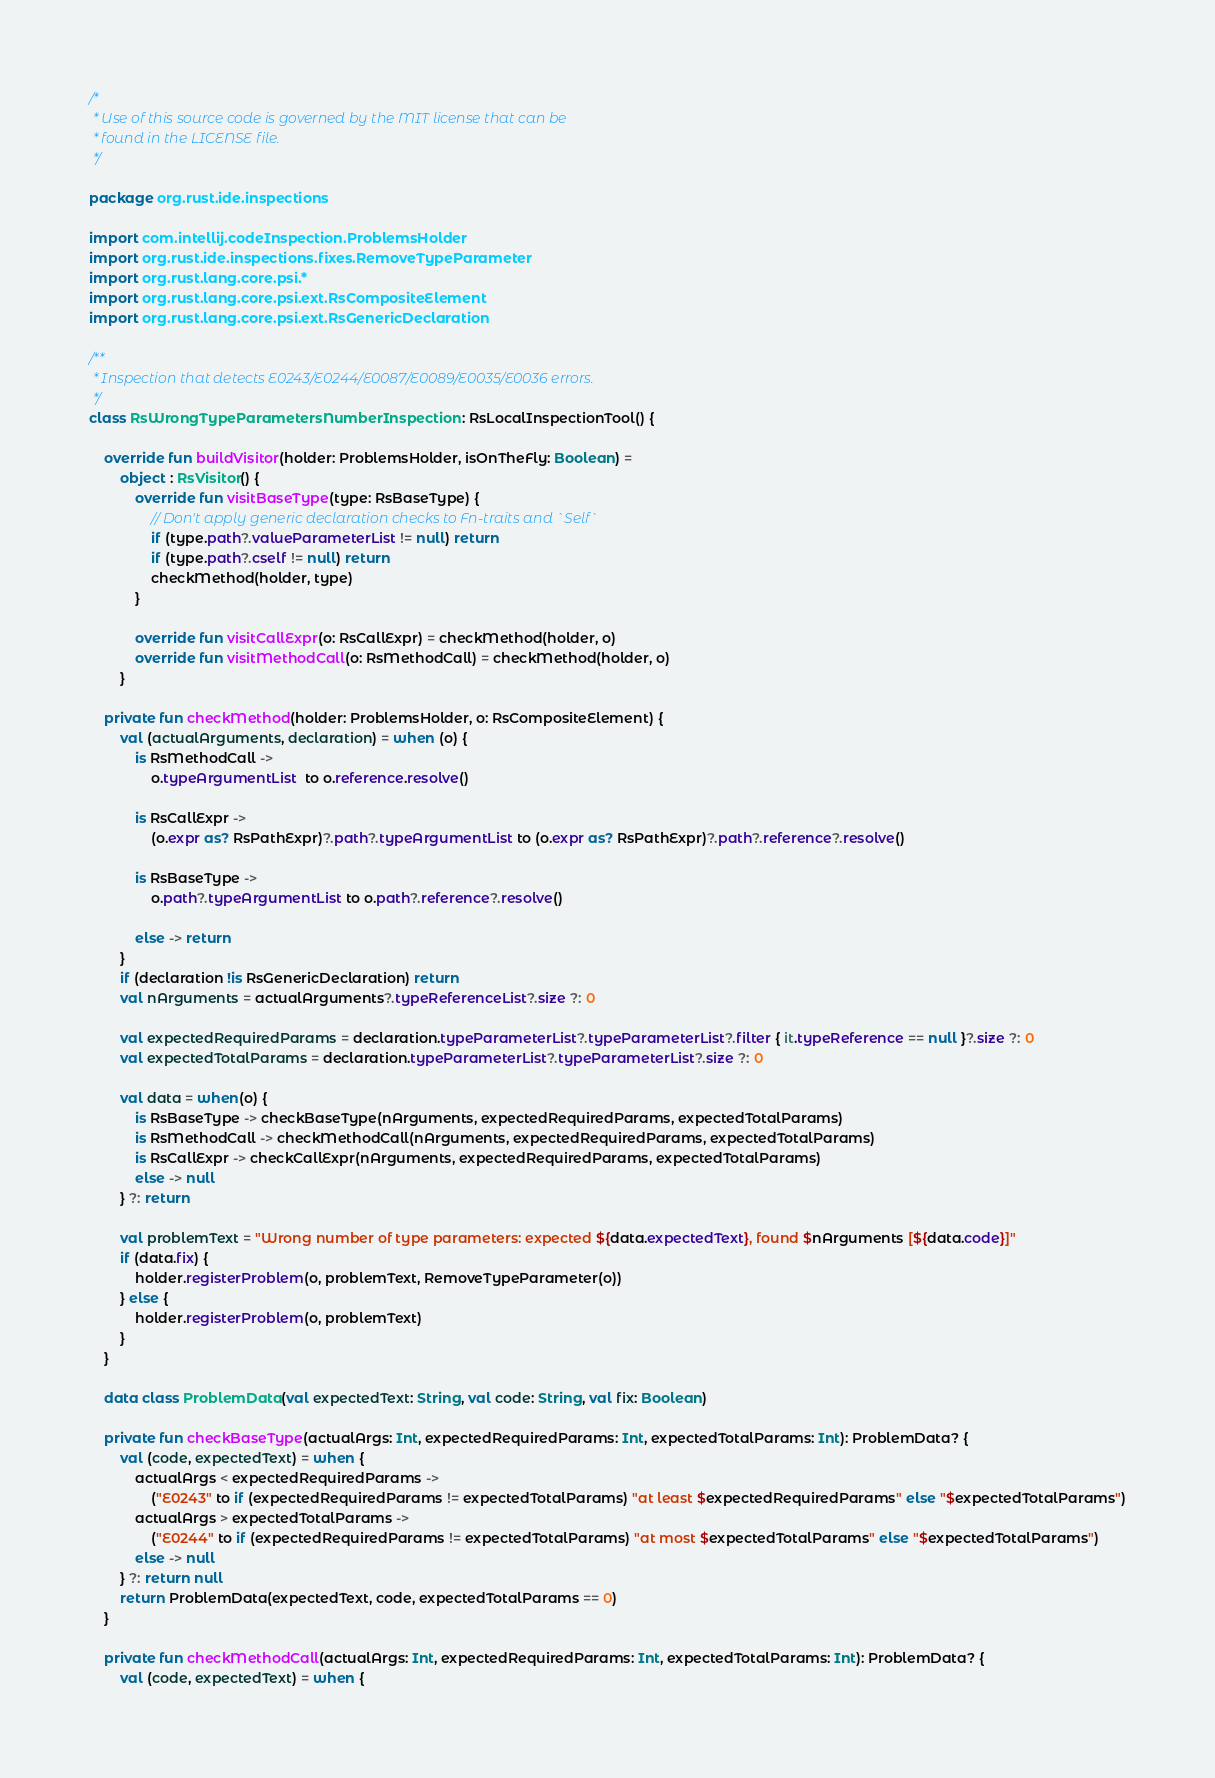<code> <loc_0><loc_0><loc_500><loc_500><_Kotlin_>/*
 * Use of this source code is governed by the MIT license that can be
 * found in the LICENSE file.
 */

package org.rust.ide.inspections

import com.intellij.codeInspection.ProblemsHolder
import org.rust.ide.inspections.fixes.RemoveTypeParameter
import org.rust.lang.core.psi.*
import org.rust.lang.core.psi.ext.RsCompositeElement
import org.rust.lang.core.psi.ext.RsGenericDeclaration

/**
 * Inspection that detects E0243/E0244/E0087/E0089/E0035/E0036 errors.
 */
class RsWrongTypeParametersNumberInspection : RsLocalInspectionTool() {

    override fun buildVisitor(holder: ProblemsHolder, isOnTheFly: Boolean) =
        object : RsVisitor() {
            override fun visitBaseType(type: RsBaseType) {
                // Don't apply generic declaration checks to Fn-traits and `Self`
                if (type.path?.valueParameterList != null) return
                if (type.path?.cself != null) return
                checkMethod(holder, type)
            }

            override fun visitCallExpr(o: RsCallExpr) = checkMethod(holder, o)
            override fun visitMethodCall(o: RsMethodCall) = checkMethod(holder, o)
        }

    private fun checkMethod(holder: ProblemsHolder, o: RsCompositeElement) {
        val (actualArguments, declaration) = when (o) {
            is RsMethodCall ->
                o.typeArgumentList  to o.reference.resolve()

            is RsCallExpr ->
                (o.expr as? RsPathExpr)?.path?.typeArgumentList to (o.expr as? RsPathExpr)?.path?.reference?.resolve()

            is RsBaseType ->
                o.path?.typeArgumentList to o.path?.reference?.resolve()

            else -> return
        }
        if (declaration !is RsGenericDeclaration) return
        val nArguments = actualArguments?.typeReferenceList?.size ?: 0

        val expectedRequiredParams = declaration.typeParameterList?.typeParameterList?.filter { it.typeReference == null }?.size ?: 0
        val expectedTotalParams = declaration.typeParameterList?.typeParameterList?.size ?: 0

        val data = when(o) {
            is RsBaseType -> checkBaseType(nArguments, expectedRequiredParams, expectedTotalParams)
            is RsMethodCall -> checkMethodCall(nArguments, expectedRequiredParams, expectedTotalParams)
            is RsCallExpr -> checkCallExpr(nArguments, expectedRequiredParams, expectedTotalParams)
            else -> null
        } ?: return

        val problemText = "Wrong number of type parameters: expected ${data.expectedText}, found $nArguments [${data.code}]"
        if (data.fix) {
            holder.registerProblem(o, problemText, RemoveTypeParameter(o))
        } else {
            holder.registerProblem(o, problemText)
        }
    }

    data class ProblemData(val expectedText: String, val code: String, val fix: Boolean)

    private fun checkBaseType(actualArgs: Int, expectedRequiredParams: Int, expectedTotalParams: Int): ProblemData? {
        val (code, expectedText) = when {
            actualArgs < expectedRequiredParams ->
                ("E0243" to if (expectedRequiredParams != expectedTotalParams) "at least $expectedRequiredParams" else "$expectedTotalParams")
            actualArgs > expectedTotalParams ->
                ("E0244" to if (expectedRequiredParams != expectedTotalParams) "at most $expectedTotalParams" else "$expectedTotalParams")
            else -> null
        } ?: return null
        return ProblemData(expectedText, code, expectedTotalParams == 0)
    }

    private fun checkMethodCall(actualArgs: Int, expectedRequiredParams: Int, expectedTotalParams: Int): ProblemData? {
        val (code, expectedText) = when {</code> 